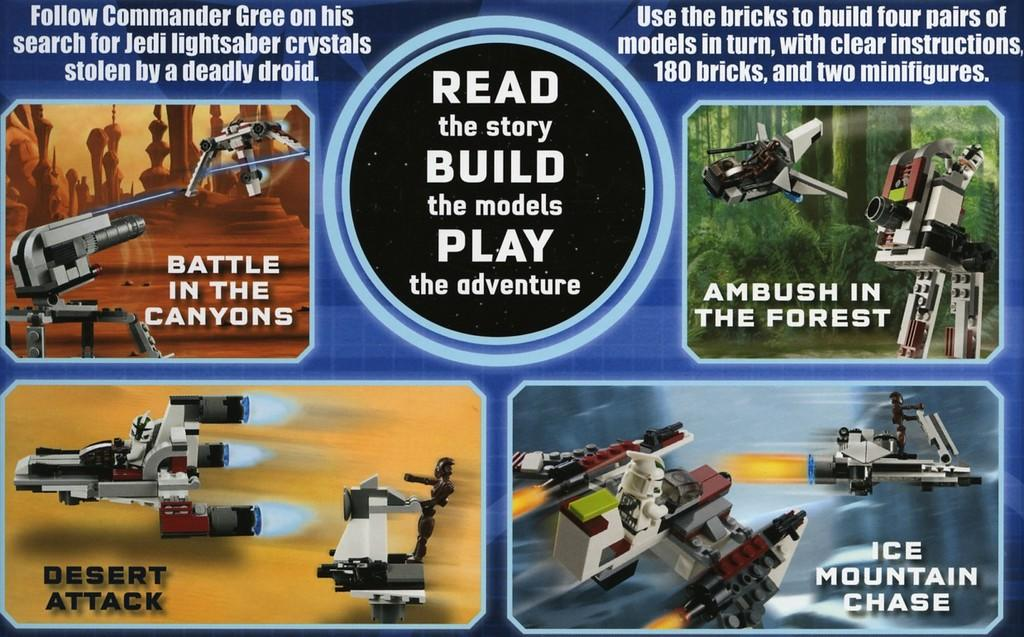<image>
Write a terse but informative summary of the picture. A Star Wars playset promises that people can read, build and play with it. 